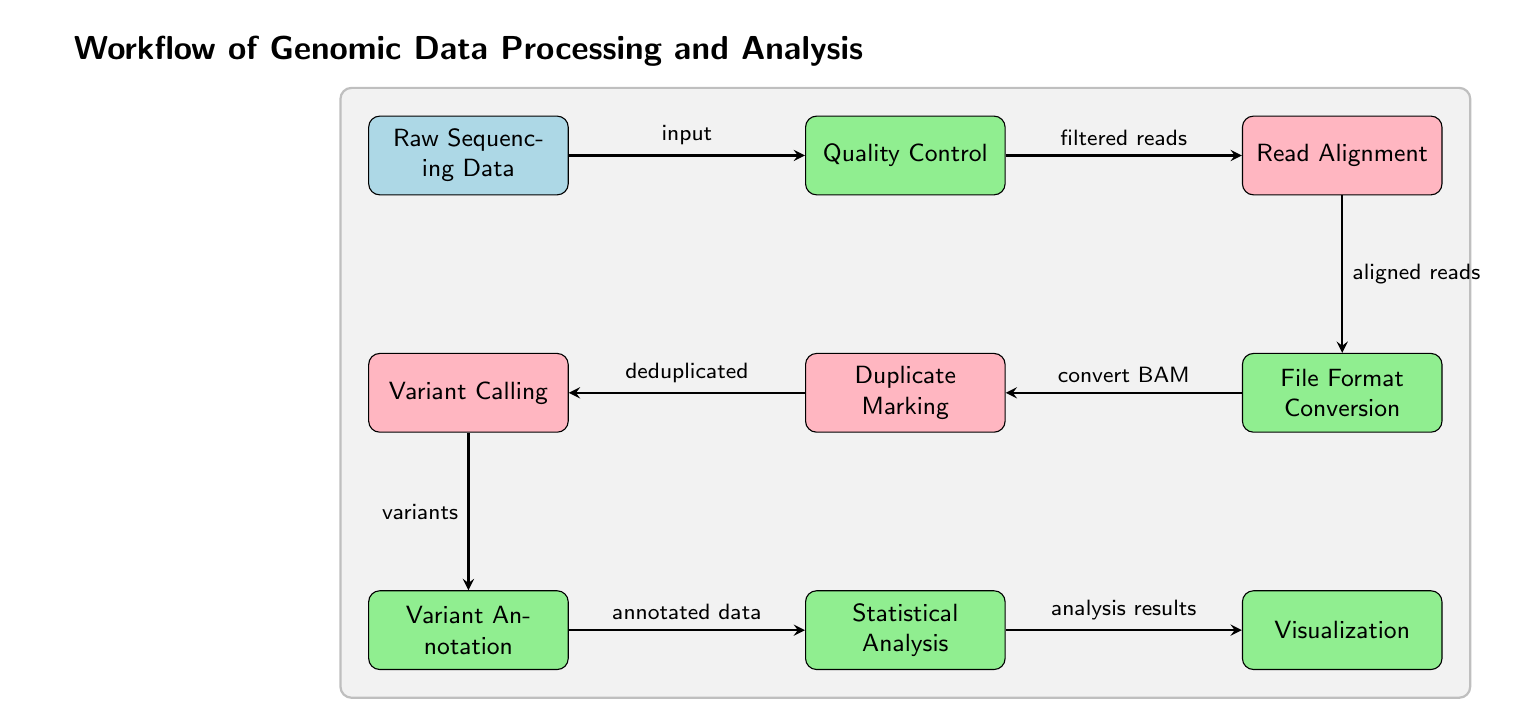What is the first node in the workflow? The first node in the workflow is labeled as "Raw Sequencing Data". This is identified as the starting point when analyzing the diagram.
Answer: Raw Sequencing Data How many processing steps are shown in the diagram? The processing steps represented in the diagram are "Quality Control", "File Format Conversion", "Variant Annotation", "Statistical Analysis", and "Visualization". Counting these nodes gives a total of five processing steps.
Answer: 5 What algorithm comes after "Read Alignment"? The algorithm that follows "Read Alignment" is labeled "File Format Conversion". This relationship is established through the directional arrow leading from the "Read Alignment" node to the "File Format Conversion" node.
Answer: File Format Conversion What is the output of the "Variant Calling" algorithm? The output of the "Variant Calling" algorithm is described as "variants". This is indicated by the arrow leading out of "Variant Calling" pointing towards the "Variant Annotation" process.
Answer: variants Which process follows the "Quality Control" step? The process that follows "Quality Control" is identified as "Read Alignment". This is evidenced by the directed arrow leading from "Quality Control" to "Read Alignment".
Answer: Read Alignment How are "Duplicate Marking" and "Variant Calling" related? "Duplicate Marking" comes before "Variant Calling" in the workflow. The arrow shows that deduplicated reads produced by "Duplicate Marking" are fed into "Variant Calling" as input. This establishes a sequential relationship between these two algorithms.
Answer: Sequential relationship What is the final output of the workflow? The final output of the workflow is indicated as "analysis results". This is provided by the last process, "Visualization", which outputs the results of the analysis done in the preceding steps.
Answer: analysis results Which nodes have a green color? The nodes that have a green color, indicating processes, are "Quality Control", "File Format Conversion", "Variant Annotation", "Statistical Analysis", and "Visualization". These nodes can be distinguished by their fill color in the diagram.
Answer: 5 